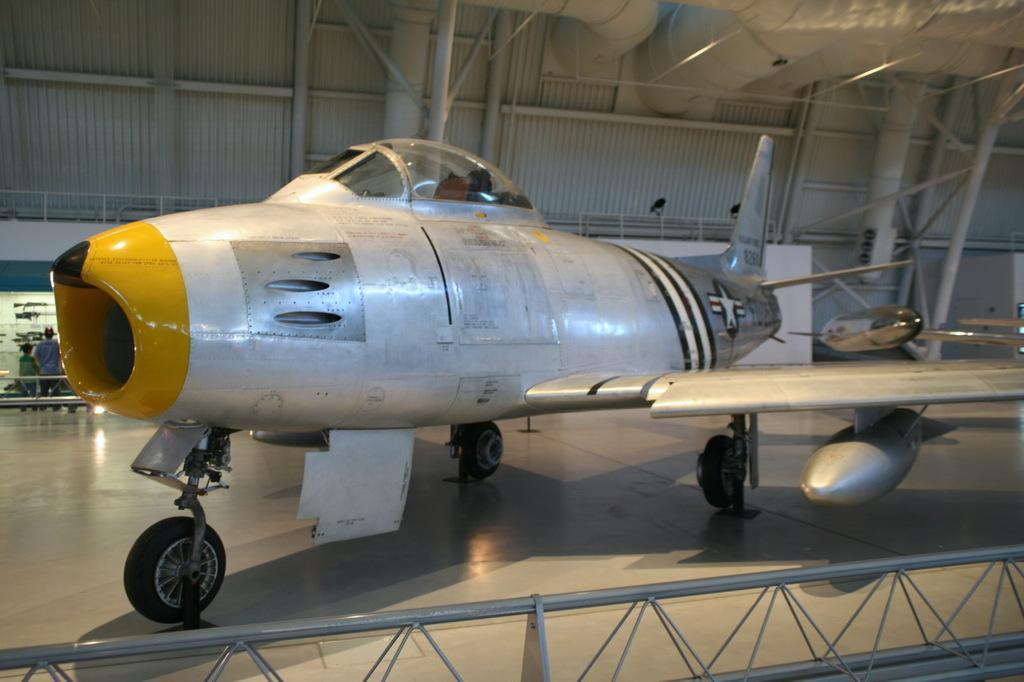Could you give a brief overview of what you see in this image? In this image there is an aircraft on the floor. At the top there are pipes and rods. In the background there are two people standing near the store. At the bottom there is an iron rod. 